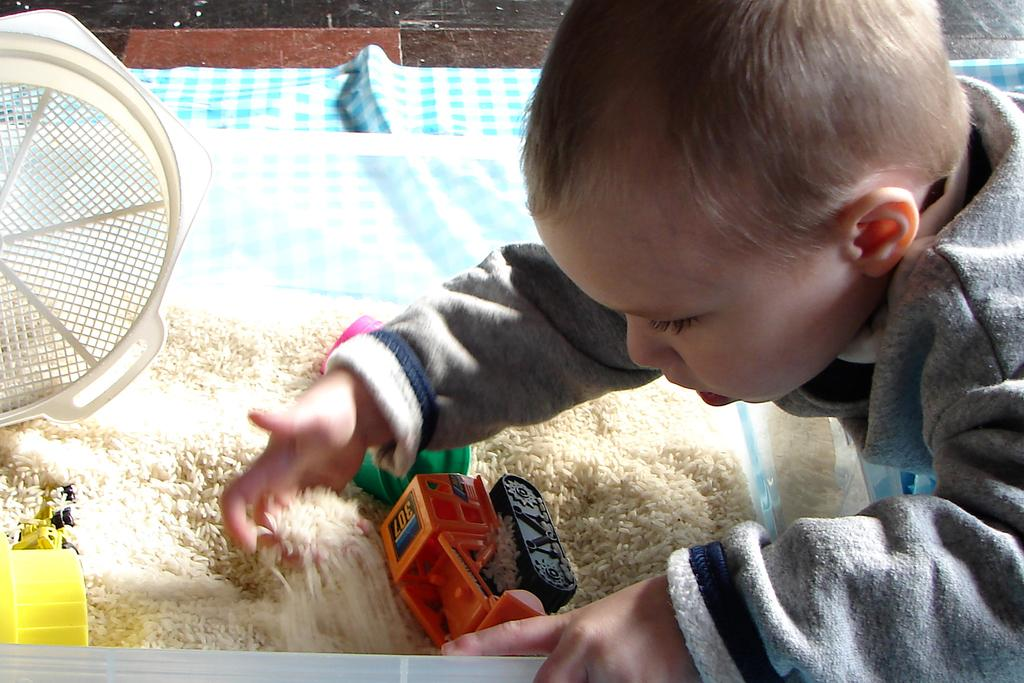What is the main subject of the image? The main subject of the image is a child. What is the child doing in the image? The child is playing with toys and rice. What type of cheese can be seen in the image? There is no cheese present in the image. Is the child playing with toys and rice during the night? The time of day is not mentioned in the image, so it cannot be determined if the child is playing during the night. 